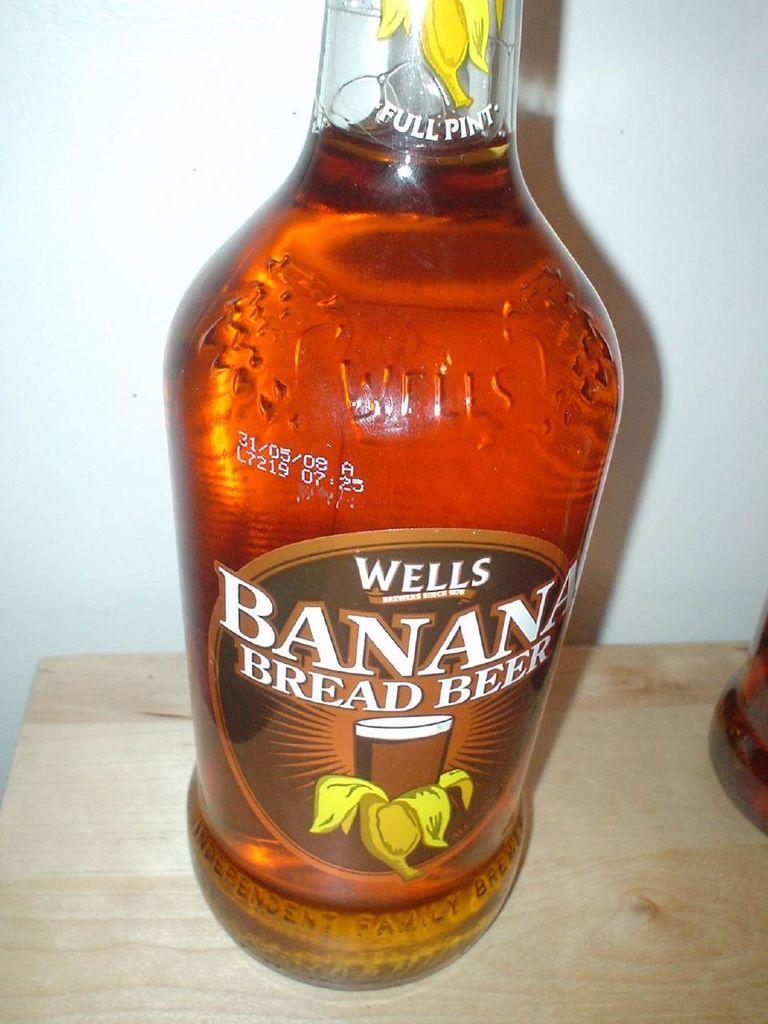<image>
Provide a brief description of the given image. a bottle of Wells Banana Bread Beer sits on a table. 